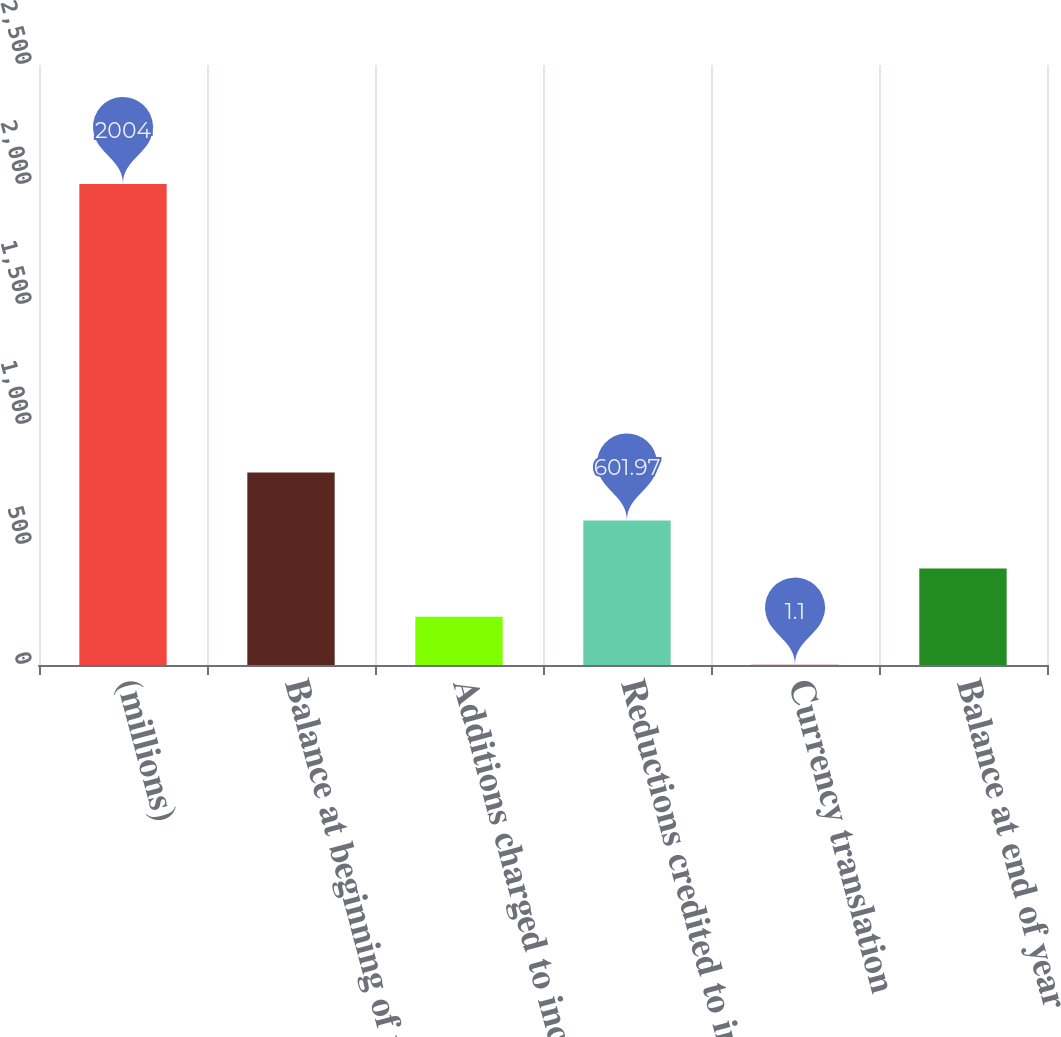Convert chart to OTSL. <chart><loc_0><loc_0><loc_500><loc_500><bar_chart><fcel>(millions)<fcel>Balance at beginning of year<fcel>Additions charged to income<fcel>Reductions credited to income<fcel>Currency translation<fcel>Balance at end of year<nl><fcel>2004<fcel>802.26<fcel>201.39<fcel>601.97<fcel>1.1<fcel>401.68<nl></chart> 